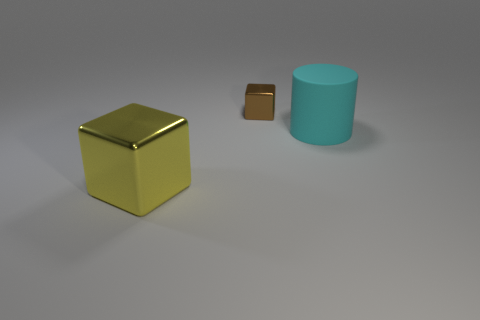Add 2 big brown matte cylinders. How many objects exist? 5 Add 3 yellow things. How many yellow things are left? 4 Add 1 big matte cylinders. How many big matte cylinders exist? 2 Subtract all yellow blocks. How many blocks are left? 1 Subtract 0 red cylinders. How many objects are left? 3 Subtract all cylinders. How many objects are left? 2 Subtract 2 cubes. How many cubes are left? 0 Subtract all purple cylinders. Subtract all cyan cubes. How many cylinders are left? 1 Subtract all cyan cylinders. How many red cubes are left? 0 Subtract all cubes. Subtract all large brown matte blocks. How many objects are left? 1 